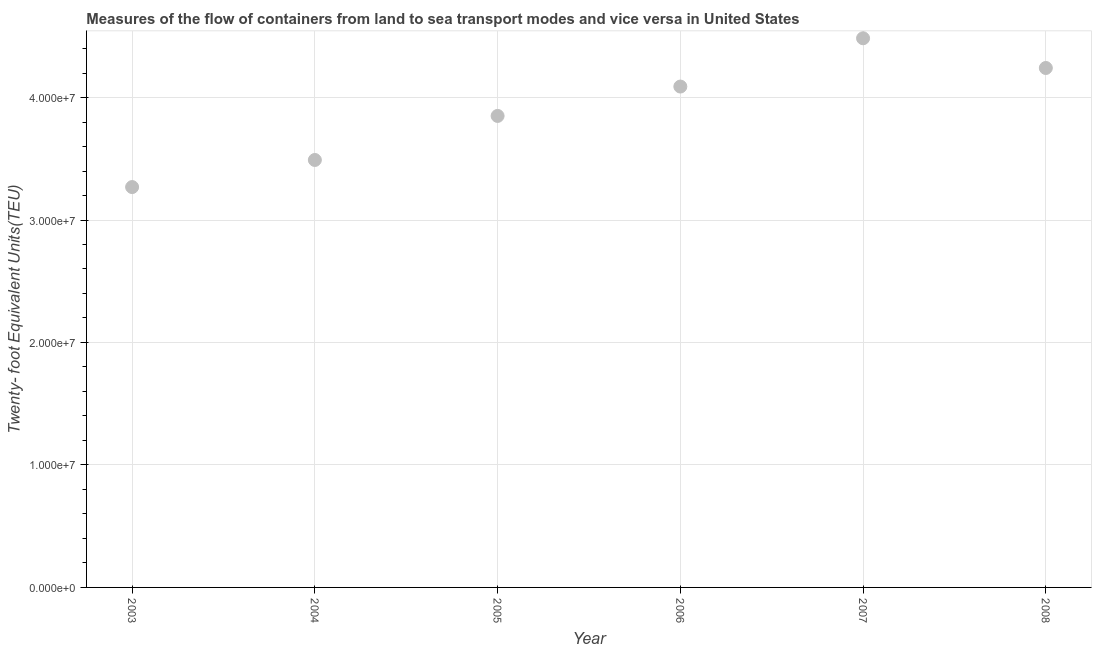What is the container port traffic in 2005?
Provide a short and direct response. 3.85e+07. Across all years, what is the maximum container port traffic?
Give a very brief answer. 4.48e+07. Across all years, what is the minimum container port traffic?
Ensure brevity in your answer.  3.27e+07. In which year was the container port traffic minimum?
Your answer should be compact. 2003. What is the sum of the container port traffic?
Your response must be concise. 2.34e+08. What is the difference between the container port traffic in 2004 and 2005?
Make the answer very short. -3.60e+06. What is the average container port traffic per year?
Provide a short and direct response. 3.90e+07. What is the median container port traffic?
Provide a succinct answer. 3.97e+07. What is the ratio of the container port traffic in 2003 to that in 2005?
Keep it short and to the point. 0.85. Is the difference between the container port traffic in 2004 and 2007 greater than the difference between any two years?
Your answer should be compact. No. What is the difference between the highest and the second highest container port traffic?
Your answer should be very brief. 2.43e+06. Is the sum of the container port traffic in 2006 and 2008 greater than the maximum container port traffic across all years?
Ensure brevity in your answer.  Yes. What is the difference between the highest and the lowest container port traffic?
Your response must be concise. 1.21e+07. In how many years, is the container port traffic greater than the average container port traffic taken over all years?
Your response must be concise. 3. How many years are there in the graph?
Make the answer very short. 6. What is the difference between two consecutive major ticks on the Y-axis?
Offer a terse response. 1.00e+07. Are the values on the major ticks of Y-axis written in scientific E-notation?
Give a very brief answer. Yes. Does the graph contain grids?
Offer a very short reply. Yes. What is the title of the graph?
Your answer should be compact. Measures of the flow of containers from land to sea transport modes and vice versa in United States. What is the label or title of the X-axis?
Your answer should be very brief. Year. What is the label or title of the Y-axis?
Your response must be concise. Twenty- foot Equivalent Units(TEU). What is the Twenty- foot Equivalent Units(TEU) in 2003?
Give a very brief answer. 3.27e+07. What is the Twenty- foot Equivalent Units(TEU) in 2004?
Ensure brevity in your answer.  3.49e+07. What is the Twenty- foot Equivalent Units(TEU) in 2005?
Provide a short and direct response. 3.85e+07. What is the Twenty- foot Equivalent Units(TEU) in 2006?
Keep it short and to the point. 4.09e+07. What is the Twenty- foot Equivalent Units(TEU) in 2007?
Ensure brevity in your answer.  4.48e+07. What is the Twenty- foot Equivalent Units(TEU) in 2008?
Give a very brief answer. 4.24e+07. What is the difference between the Twenty- foot Equivalent Units(TEU) in 2003 and 2004?
Provide a short and direct response. -2.21e+06. What is the difference between the Twenty- foot Equivalent Units(TEU) in 2003 and 2005?
Provide a succinct answer. -5.81e+06. What is the difference between the Twenty- foot Equivalent Units(TEU) in 2003 and 2006?
Keep it short and to the point. -8.21e+06. What is the difference between the Twenty- foot Equivalent Units(TEU) in 2003 and 2007?
Your answer should be very brief. -1.21e+07. What is the difference between the Twenty- foot Equivalent Units(TEU) in 2003 and 2008?
Give a very brief answer. -9.72e+06. What is the difference between the Twenty- foot Equivalent Units(TEU) in 2004 and 2005?
Give a very brief answer. -3.60e+06. What is the difference between the Twenty- foot Equivalent Units(TEU) in 2004 and 2006?
Provide a succinct answer. -6.00e+06. What is the difference between the Twenty- foot Equivalent Units(TEU) in 2004 and 2007?
Offer a terse response. -9.94e+06. What is the difference between the Twenty- foot Equivalent Units(TEU) in 2004 and 2008?
Give a very brief answer. -7.51e+06. What is the difference between the Twenty- foot Equivalent Units(TEU) in 2005 and 2006?
Offer a terse response. -2.40e+06. What is the difference between the Twenty- foot Equivalent Units(TEU) in 2005 and 2007?
Ensure brevity in your answer.  -6.34e+06. What is the difference between the Twenty- foot Equivalent Units(TEU) in 2005 and 2008?
Your answer should be compact. -3.91e+06. What is the difference between the Twenty- foot Equivalent Units(TEU) in 2006 and 2007?
Keep it short and to the point. -3.94e+06. What is the difference between the Twenty- foot Equivalent Units(TEU) in 2006 and 2008?
Your answer should be very brief. -1.52e+06. What is the difference between the Twenty- foot Equivalent Units(TEU) in 2007 and 2008?
Make the answer very short. 2.43e+06. What is the ratio of the Twenty- foot Equivalent Units(TEU) in 2003 to that in 2004?
Provide a short and direct response. 0.94. What is the ratio of the Twenty- foot Equivalent Units(TEU) in 2003 to that in 2005?
Ensure brevity in your answer.  0.85. What is the ratio of the Twenty- foot Equivalent Units(TEU) in 2003 to that in 2006?
Your response must be concise. 0.8. What is the ratio of the Twenty- foot Equivalent Units(TEU) in 2003 to that in 2007?
Provide a short and direct response. 0.73. What is the ratio of the Twenty- foot Equivalent Units(TEU) in 2003 to that in 2008?
Your answer should be compact. 0.77. What is the ratio of the Twenty- foot Equivalent Units(TEU) in 2004 to that in 2005?
Ensure brevity in your answer.  0.91. What is the ratio of the Twenty- foot Equivalent Units(TEU) in 2004 to that in 2006?
Give a very brief answer. 0.85. What is the ratio of the Twenty- foot Equivalent Units(TEU) in 2004 to that in 2007?
Ensure brevity in your answer.  0.78. What is the ratio of the Twenty- foot Equivalent Units(TEU) in 2004 to that in 2008?
Provide a succinct answer. 0.82. What is the ratio of the Twenty- foot Equivalent Units(TEU) in 2005 to that in 2006?
Your answer should be very brief. 0.94. What is the ratio of the Twenty- foot Equivalent Units(TEU) in 2005 to that in 2007?
Your answer should be compact. 0.86. What is the ratio of the Twenty- foot Equivalent Units(TEU) in 2005 to that in 2008?
Your response must be concise. 0.91. What is the ratio of the Twenty- foot Equivalent Units(TEU) in 2006 to that in 2007?
Offer a very short reply. 0.91. What is the ratio of the Twenty- foot Equivalent Units(TEU) in 2006 to that in 2008?
Offer a terse response. 0.96. What is the ratio of the Twenty- foot Equivalent Units(TEU) in 2007 to that in 2008?
Provide a succinct answer. 1.06. 